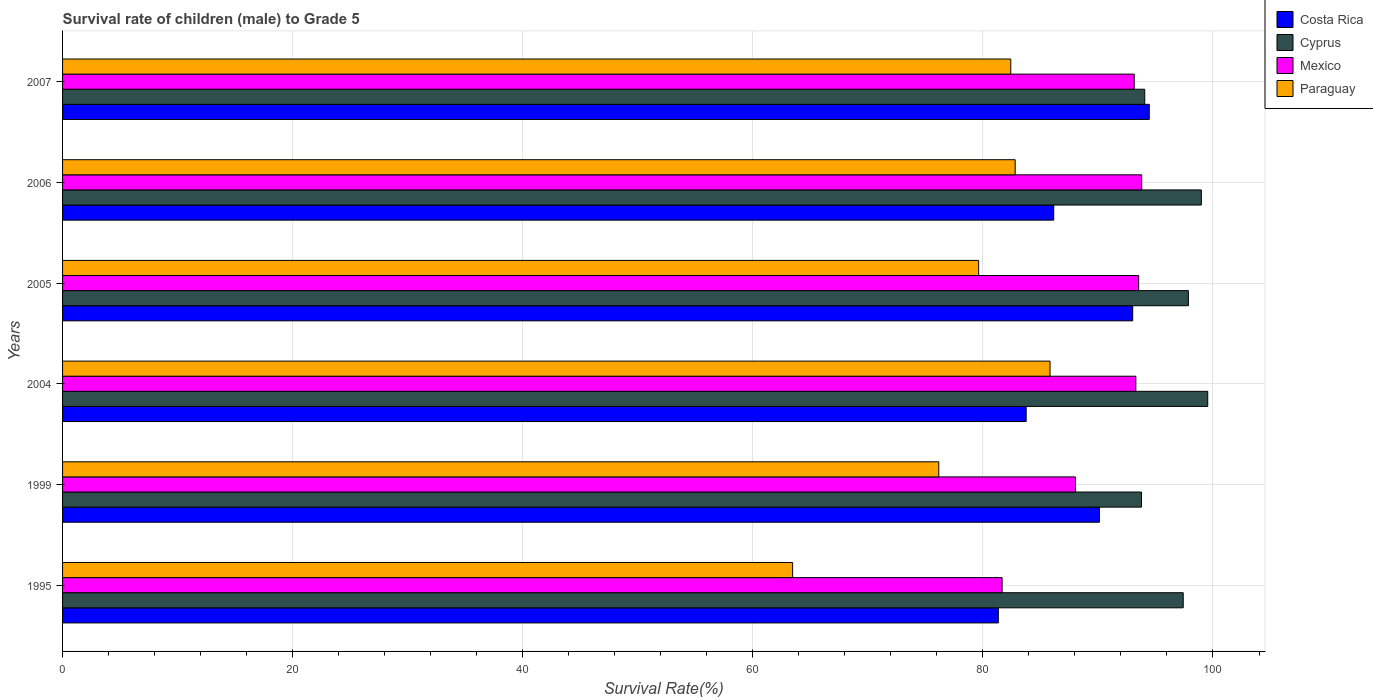How many different coloured bars are there?
Your answer should be very brief. 4. How many groups of bars are there?
Give a very brief answer. 6. Are the number of bars on each tick of the Y-axis equal?
Your answer should be very brief. Yes. How many bars are there on the 5th tick from the top?
Make the answer very short. 4. What is the label of the 2nd group of bars from the top?
Your answer should be compact. 2006. In how many cases, is the number of bars for a given year not equal to the number of legend labels?
Give a very brief answer. 0. What is the survival rate of male children to grade 5 in Paraguay in 2005?
Provide a short and direct response. 79.63. Across all years, what is the maximum survival rate of male children to grade 5 in Paraguay?
Make the answer very short. 85.84. Across all years, what is the minimum survival rate of male children to grade 5 in Cyprus?
Your response must be concise. 93.79. In which year was the survival rate of male children to grade 5 in Cyprus maximum?
Offer a very short reply. 2004. What is the total survival rate of male children to grade 5 in Paraguay in the graph?
Offer a very short reply. 470.32. What is the difference between the survival rate of male children to grade 5 in Mexico in 2005 and that in 2006?
Ensure brevity in your answer.  -0.26. What is the difference between the survival rate of male children to grade 5 in Mexico in 1995 and the survival rate of male children to grade 5 in Paraguay in 1999?
Offer a terse response. 5.5. What is the average survival rate of male children to grade 5 in Mexico per year?
Give a very brief answer. 90.58. In the year 2007, what is the difference between the survival rate of male children to grade 5 in Cyprus and survival rate of male children to grade 5 in Paraguay?
Your answer should be compact. 11.65. What is the ratio of the survival rate of male children to grade 5 in Costa Rica in 1999 to that in 2007?
Offer a very short reply. 0.95. Is the difference between the survival rate of male children to grade 5 in Cyprus in 2005 and 2007 greater than the difference between the survival rate of male children to grade 5 in Paraguay in 2005 and 2007?
Give a very brief answer. Yes. What is the difference between the highest and the second highest survival rate of male children to grade 5 in Costa Rica?
Offer a very short reply. 1.44. What is the difference between the highest and the lowest survival rate of male children to grade 5 in Mexico?
Offer a very short reply. 12.13. In how many years, is the survival rate of male children to grade 5 in Mexico greater than the average survival rate of male children to grade 5 in Mexico taken over all years?
Ensure brevity in your answer.  4. What does the 1st bar from the top in 2005 represents?
Ensure brevity in your answer.  Paraguay. What does the 2nd bar from the bottom in 2005 represents?
Give a very brief answer. Cyprus. Is it the case that in every year, the sum of the survival rate of male children to grade 5 in Mexico and survival rate of male children to grade 5 in Paraguay is greater than the survival rate of male children to grade 5 in Cyprus?
Your answer should be compact. Yes. How many bars are there?
Provide a succinct answer. 24. Does the graph contain any zero values?
Provide a short and direct response. No. How are the legend labels stacked?
Offer a very short reply. Vertical. What is the title of the graph?
Make the answer very short. Survival rate of children (male) to Grade 5. What is the label or title of the X-axis?
Provide a succinct answer. Survival Rate(%). What is the Survival Rate(%) of Costa Rica in 1995?
Offer a very short reply. 81.34. What is the Survival Rate(%) of Cyprus in 1995?
Offer a terse response. 97.41. What is the Survival Rate(%) of Mexico in 1995?
Provide a succinct answer. 81.67. What is the Survival Rate(%) in Paraguay in 1995?
Provide a succinct answer. 63.46. What is the Survival Rate(%) in Costa Rica in 1999?
Offer a very short reply. 90.13. What is the Survival Rate(%) in Cyprus in 1999?
Your answer should be very brief. 93.79. What is the Survival Rate(%) of Mexico in 1999?
Your answer should be very brief. 88.05. What is the Survival Rate(%) in Paraguay in 1999?
Make the answer very short. 76.17. What is the Survival Rate(%) in Costa Rica in 2004?
Offer a terse response. 83.76. What is the Survival Rate(%) of Cyprus in 2004?
Provide a succinct answer. 99.54. What is the Survival Rate(%) of Mexico in 2004?
Provide a short and direct response. 93.29. What is the Survival Rate(%) of Paraguay in 2004?
Offer a very short reply. 85.84. What is the Survival Rate(%) in Costa Rica in 2005?
Give a very brief answer. 93.02. What is the Survival Rate(%) of Cyprus in 2005?
Your response must be concise. 97.86. What is the Survival Rate(%) of Mexico in 2005?
Provide a short and direct response. 93.54. What is the Survival Rate(%) of Paraguay in 2005?
Give a very brief answer. 79.63. What is the Survival Rate(%) in Costa Rica in 2006?
Provide a short and direct response. 86.16. What is the Survival Rate(%) in Cyprus in 2006?
Offer a terse response. 98.99. What is the Survival Rate(%) in Mexico in 2006?
Offer a very short reply. 93.8. What is the Survival Rate(%) in Paraguay in 2006?
Make the answer very short. 82.8. What is the Survival Rate(%) in Costa Rica in 2007?
Provide a succinct answer. 94.46. What is the Survival Rate(%) of Cyprus in 2007?
Ensure brevity in your answer.  94.07. What is the Survival Rate(%) in Mexico in 2007?
Your answer should be very brief. 93.15. What is the Survival Rate(%) in Paraguay in 2007?
Provide a short and direct response. 82.42. Across all years, what is the maximum Survival Rate(%) of Costa Rica?
Give a very brief answer. 94.46. Across all years, what is the maximum Survival Rate(%) of Cyprus?
Provide a succinct answer. 99.54. Across all years, what is the maximum Survival Rate(%) in Mexico?
Make the answer very short. 93.8. Across all years, what is the maximum Survival Rate(%) of Paraguay?
Ensure brevity in your answer.  85.84. Across all years, what is the minimum Survival Rate(%) of Costa Rica?
Ensure brevity in your answer.  81.34. Across all years, what is the minimum Survival Rate(%) of Cyprus?
Provide a succinct answer. 93.79. Across all years, what is the minimum Survival Rate(%) of Mexico?
Your answer should be compact. 81.67. Across all years, what is the minimum Survival Rate(%) in Paraguay?
Keep it short and to the point. 63.46. What is the total Survival Rate(%) in Costa Rica in the graph?
Ensure brevity in your answer.  528.87. What is the total Survival Rate(%) in Cyprus in the graph?
Keep it short and to the point. 581.65. What is the total Survival Rate(%) of Mexico in the graph?
Your answer should be compact. 543.51. What is the total Survival Rate(%) in Paraguay in the graph?
Offer a very short reply. 470.32. What is the difference between the Survival Rate(%) in Costa Rica in 1995 and that in 1999?
Offer a very short reply. -8.79. What is the difference between the Survival Rate(%) of Cyprus in 1995 and that in 1999?
Provide a succinct answer. 3.63. What is the difference between the Survival Rate(%) of Mexico in 1995 and that in 1999?
Offer a terse response. -6.38. What is the difference between the Survival Rate(%) of Paraguay in 1995 and that in 1999?
Give a very brief answer. -12.71. What is the difference between the Survival Rate(%) in Costa Rica in 1995 and that in 2004?
Your answer should be compact. -2.42. What is the difference between the Survival Rate(%) of Cyprus in 1995 and that in 2004?
Provide a succinct answer. -2.13. What is the difference between the Survival Rate(%) in Mexico in 1995 and that in 2004?
Give a very brief answer. -11.63. What is the difference between the Survival Rate(%) in Paraguay in 1995 and that in 2004?
Ensure brevity in your answer.  -22.38. What is the difference between the Survival Rate(%) in Costa Rica in 1995 and that in 2005?
Offer a very short reply. -11.68. What is the difference between the Survival Rate(%) in Cyprus in 1995 and that in 2005?
Provide a succinct answer. -0.45. What is the difference between the Survival Rate(%) in Mexico in 1995 and that in 2005?
Ensure brevity in your answer.  -11.87. What is the difference between the Survival Rate(%) in Paraguay in 1995 and that in 2005?
Give a very brief answer. -16.17. What is the difference between the Survival Rate(%) of Costa Rica in 1995 and that in 2006?
Give a very brief answer. -4.82. What is the difference between the Survival Rate(%) in Cyprus in 1995 and that in 2006?
Offer a very short reply. -1.58. What is the difference between the Survival Rate(%) of Mexico in 1995 and that in 2006?
Your answer should be compact. -12.13. What is the difference between the Survival Rate(%) in Paraguay in 1995 and that in 2006?
Provide a succinct answer. -19.34. What is the difference between the Survival Rate(%) in Costa Rica in 1995 and that in 2007?
Your answer should be compact. -13.12. What is the difference between the Survival Rate(%) of Cyprus in 1995 and that in 2007?
Your answer should be very brief. 3.34. What is the difference between the Survival Rate(%) in Mexico in 1995 and that in 2007?
Provide a succinct answer. -11.48. What is the difference between the Survival Rate(%) in Paraguay in 1995 and that in 2007?
Keep it short and to the point. -18.96. What is the difference between the Survival Rate(%) in Costa Rica in 1999 and that in 2004?
Offer a terse response. 6.37. What is the difference between the Survival Rate(%) of Cyprus in 1999 and that in 2004?
Offer a terse response. -5.76. What is the difference between the Survival Rate(%) of Mexico in 1999 and that in 2004?
Ensure brevity in your answer.  -5.24. What is the difference between the Survival Rate(%) of Paraguay in 1999 and that in 2004?
Provide a succinct answer. -9.67. What is the difference between the Survival Rate(%) in Costa Rica in 1999 and that in 2005?
Offer a terse response. -2.89. What is the difference between the Survival Rate(%) in Cyprus in 1999 and that in 2005?
Offer a very short reply. -4.08. What is the difference between the Survival Rate(%) in Mexico in 1999 and that in 2005?
Your answer should be very brief. -5.49. What is the difference between the Survival Rate(%) in Paraguay in 1999 and that in 2005?
Keep it short and to the point. -3.46. What is the difference between the Survival Rate(%) of Costa Rica in 1999 and that in 2006?
Keep it short and to the point. 3.97. What is the difference between the Survival Rate(%) of Cyprus in 1999 and that in 2006?
Offer a very short reply. -5.2. What is the difference between the Survival Rate(%) in Mexico in 1999 and that in 2006?
Keep it short and to the point. -5.75. What is the difference between the Survival Rate(%) in Paraguay in 1999 and that in 2006?
Your response must be concise. -6.64. What is the difference between the Survival Rate(%) in Costa Rica in 1999 and that in 2007?
Ensure brevity in your answer.  -4.33. What is the difference between the Survival Rate(%) in Cyprus in 1999 and that in 2007?
Provide a short and direct response. -0.28. What is the difference between the Survival Rate(%) in Mexico in 1999 and that in 2007?
Your answer should be very brief. -5.1. What is the difference between the Survival Rate(%) in Paraguay in 1999 and that in 2007?
Keep it short and to the point. -6.26. What is the difference between the Survival Rate(%) of Costa Rica in 2004 and that in 2005?
Provide a succinct answer. -9.26. What is the difference between the Survival Rate(%) in Cyprus in 2004 and that in 2005?
Your answer should be compact. 1.68. What is the difference between the Survival Rate(%) in Mexico in 2004 and that in 2005?
Your response must be concise. -0.24. What is the difference between the Survival Rate(%) of Paraguay in 2004 and that in 2005?
Your answer should be very brief. 6.21. What is the difference between the Survival Rate(%) in Costa Rica in 2004 and that in 2006?
Ensure brevity in your answer.  -2.39. What is the difference between the Survival Rate(%) of Cyprus in 2004 and that in 2006?
Offer a very short reply. 0.56. What is the difference between the Survival Rate(%) in Mexico in 2004 and that in 2006?
Ensure brevity in your answer.  -0.51. What is the difference between the Survival Rate(%) in Paraguay in 2004 and that in 2006?
Your response must be concise. 3.03. What is the difference between the Survival Rate(%) of Costa Rica in 2004 and that in 2007?
Offer a terse response. -10.7. What is the difference between the Survival Rate(%) in Cyprus in 2004 and that in 2007?
Ensure brevity in your answer.  5.48. What is the difference between the Survival Rate(%) in Mexico in 2004 and that in 2007?
Make the answer very short. 0.14. What is the difference between the Survival Rate(%) of Paraguay in 2004 and that in 2007?
Your answer should be very brief. 3.42. What is the difference between the Survival Rate(%) of Costa Rica in 2005 and that in 2006?
Offer a very short reply. 6.87. What is the difference between the Survival Rate(%) in Cyprus in 2005 and that in 2006?
Keep it short and to the point. -1.13. What is the difference between the Survival Rate(%) of Mexico in 2005 and that in 2006?
Your answer should be very brief. -0.26. What is the difference between the Survival Rate(%) in Paraguay in 2005 and that in 2006?
Provide a short and direct response. -3.17. What is the difference between the Survival Rate(%) of Costa Rica in 2005 and that in 2007?
Your answer should be very brief. -1.44. What is the difference between the Survival Rate(%) in Cyprus in 2005 and that in 2007?
Your answer should be compact. 3.79. What is the difference between the Survival Rate(%) of Mexico in 2005 and that in 2007?
Ensure brevity in your answer.  0.39. What is the difference between the Survival Rate(%) in Paraguay in 2005 and that in 2007?
Your answer should be very brief. -2.79. What is the difference between the Survival Rate(%) of Costa Rica in 2006 and that in 2007?
Ensure brevity in your answer.  -8.31. What is the difference between the Survival Rate(%) in Cyprus in 2006 and that in 2007?
Your response must be concise. 4.92. What is the difference between the Survival Rate(%) of Mexico in 2006 and that in 2007?
Make the answer very short. 0.65. What is the difference between the Survival Rate(%) of Paraguay in 2006 and that in 2007?
Make the answer very short. 0.38. What is the difference between the Survival Rate(%) of Costa Rica in 1995 and the Survival Rate(%) of Cyprus in 1999?
Ensure brevity in your answer.  -12.45. What is the difference between the Survival Rate(%) of Costa Rica in 1995 and the Survival Rate(%) of Mexico in 1999?
Your answer should be compact. -6.71. What is the difference between the Survival Rate(%) in Costa Rica in 1995 and the Survival Rate(%) in Paraguay in 1999?
Your response must be concise. 5.17. What is the difference between the Survival Rate(%) in Cyprus in 1995 and the Survival Rate(%) in Mexico in 1999?
Provide a succinct answer. 9.36. What is the difference between the Survival Rate(%) in Cyprus in 1995 and the Survival Rate(%) in Paraguay in 1999?
Offer a terse response. 21.25. What is the difference between the Survival Rate(%) in Mexico in 1995 and the Survival Rate(%) in Paraguay in 1999?
Keep it short and to the point. 5.5. What is the difference between the Survival Rate(%) of Costa Rica in 1995 and the Survival Rate(%) of Cyprus in 2004?
Offer a very short reply. -18.2. What is the difference between the Survival Rate(%) of Costa Rica in 1995 and the Survival Rate(%) of Mexico in 2004?
Make the answer very short. -11.95. What is the difference between the Survival Rate(%) of Costa Rica in 1995 and the Survival Rate(%) of Paraguay in 2004?
Make the answer very short. -4.5. What is the difference between the Survival Rate(%) in Cyprus in 1995 and the Survival Rate(%) in Mexico in 2004?
Keep it short and to the point. 4.12. What is the difference between the Survival Rate(%) in Cyprus in 1995 and the Survival Rate(%) in Paraguay in 2004?
Give a very brief answer. 11.57. What is the difference between the Survival Rate(%) of Mexico in 1995 and the Survival Rate(%) of Paraguay in 2004?
Make the answer very short. -4.17. What is the difference between the Survival Rate(%) in Costa Rica in 1995 and the Survival Rate(%) in Cyprus in 2005?
Make the answer very short. -16.52. What is the difference between the Survival Rate(%) in Costa Rica in 1995 and the Survival Rate(%) in Mexico in 2005?
Provide a short and direct response. -12.2. What is the difference between the Survival Rate(%) in Costa Rica in 1995 and the Survival Rate(%) in Paraguay in 2005?
Provide a short and direct response. 1.71. What is the difference between the Survival Rate(%) in Cyprus in 1995 and the Survival Rate(%) in Mexico in 2005?
Offer a very short reply. 3.87. What is the difference between the Survival Rate(%) in Cyprus in 1995 and the Survival Rate(%) in Paraguay in 2005?
Your answer should be compact. 17.78. What is the difference between the Survival Rate(%) in Mexico in 1995 and the Survival Rate(%) in Paraguay in 2005?
Give a very brief answer. 2.04. What is the difference between the Survival Rate(%) in Costa Rica in 1995 and the Survival Rate(%) in Cyprus in 2006?
Give a very brief answer. -17.65. What is the difference between the Survival Rate(%) in Costa Rica in 1995 and the Survival Rate(%) in Mexico in 2006?
Offer a very short reply. -12.46. What is the difference between the Survival Rate(%) of Costa Rica in 1995 and the Survival Rate(%) of Paraguay in 2006?
Ensure brevity in your answer.  -1.46. What is the difference between the Survival Rate(%) of Cyprus in 1995 and the Survival Rate(%) of Mexico in 2006?
Your response must be concise. 3.61. What is the difference between the Survival Rate(%) in Cyprus in 1995 and the Survival Rate(%) in Paraguay in 2006?
Offer a terse response. 14.61. What is the difference between the Survival Rate(%) of Mexico in 1995 and the Survival Rate(%) of Paraguay in 2006?
Provide a succinct answer. -1.14. What is the difference between the Survival Rate(%) in Costa Rica in 1995 and the Survival Rate(%) in Cyprus in 2007?
Offer a terse response. -12.73. What is the difference between the Survival Rate(%) of Costa Rica in 1995 and the Survival Rate(%) of Mexico in 2007?
Provide a succinct answer. -11.81. What is the difference between the Survival Rate(%) in Costa Rica in 1995 and the Survival Rate(%) in Paraguay in 2007?
Offer a terse response. -1.08. What is the difference between the Survival Rate(%) in Cyprus in 1995 and the Survival Rate(%) in Mexico in 2007?
Offer a terse response. 4.26. What is the difference between the Survival Rate(%) in Cyprus in 1995 and the Survival Rate(%) in Paraguay in 2007?
Your answer should be compact. 14.99. What is the difference between the Survival Rate(%) in Mexico in 1995 and the Survival Rate(%) in Paraguay in 2007?
Provide a succinct answer. -0.75. What is the difference between the Survival Rate(%) in Costa Rica in 1999 and the Survival Rate(%) in Cyprus in 2004?
Your answer should be very brief. -9.42. What is the difference between the Survival Rate(%) in Costa Rica in 1999 and the Survival Rate(%) in Mexico in 2004?
Provide a succinct answer. -3.17. What is the difference between the Survival Rate(%) of Costa Rica in 1999 and the Survival Rate(%) of Paraguay in 2004?
Provide a short and direct response. 4.29. What is the difference between the Survival Rate(%) of Cyprus in 1999 and the Survival Rate(%) of Mexico in 2004?
Offer a terse response. 0.49. What is the difference between the Survival Rate(%) in Cyprus in 1999 and the Survival Rate(%) in Paraguay in 2004?
Offer a terse response. 7.95. What is the difference between the Survival Rate(%) in Mexico in 1999 and the Survival Rate(%) in Paraguay in 2004?
Your response must be concise. 2.21. What is the difference between the Survival Rate(%) of Costa Rica in 1999 and the Survival Rate(%) of Cyprus in 2005?
Keep it short and to the point. -7.73. What is the difference between the Survival Rate(%) in Costa Rica in 1999 and the Survival Rate(%) in Mexico in 2005?
Give a very brief answer. -3.41. What is the difference between the Survival Rate(%) in Costa Rica in 1999 and the Survival Rate(%) in Paraguay in 2005?
Make the answer very short. 10.5. What is the difference between the Survival Rate(%) of Cyprus in 1999 and the Survival Rate(%) of Mexico in 2005?
Make the answer very short. 0.25. What is the difference between the Survival Rate(%) in Cyprus in 1999 and the Survival Rate(%) in Paraguay in 2005?
Give a very brief answer. 14.16. What is the difference between the Survival Rate(%) in Mexico in 1999 and the Survival Rate(%) in Paraguay in 2005?
Ensure brevity in your answer.  8.42. What is the difference between the Survival Rate(%) of Costa Rica in 1999 and the Survival Rate(%) of Cyprus in 2006?
Your answer should be very brief. -8.86. What is the difference between the Survival Rate(%) in Costa Rica in 1999 and the Survival Rate(%) in Mexico in 2006?
Provide a short and direct response. -3.68. What is the difference between the Survival Rate(%) in Costa Rica in 1999 and the Survival Rate(%) in Paraguay in 2006?
Make the answer very short. 7.32. What is the difference between the Survival Rate(%) in Cyprus in 1999 and the Survival Rate(%) in Mexico in 2006?
Make the answer very short. -0.02. What is the difference between the Survival Rate(%) of Cyprus in 1999 and the Survival Rate(%) of Paraguay in 2006?
Give a very brief answer. 10.98. What is the difference between the Survival Rate(%) in Mexico in 1999 and the Survival Rate(%) in Paraguay in 2006?
Your answer should be compact. 5.25. What is the difference between the Survival Rate(%) of Costa Rica in 1999 and the Survival Rate(%) of Cyprus in 2007?
Ensure brevity in your answer.  -3.94. What is the difference between the Survival Rate(%) of Costa Rica in 1999 and the Survival Rate(%) of Mexico in 2007?
Keep it short and to the point. -3.02. What is the difference between the Survival Rate(%) of Costa Rica in 1999 and the Survival Rate(%) of Paraguay in 2007?
Offer a terse response. 7.71. What is the difference between the Survival Rate(%) of Cyprus in 1999 and the Survival Rate(%) of Mexico in 2007?
Your answer should be very brief. 0.63. What is the difference between the Survival Rate(%) of Cyprus in 1999 and the Survival Rate(%) of Paraguay in 2007?
Offer a very short reply. 11.36. What is the difference between the Survival Rate(%) in Mexico in 1999 and the Survival Rate(%) in Paraguay in 2007?
Provide a succinct answer. 5.63. What is the difference between the Survival Rate(%) in Costa Rica in 2004 and the Survival Rate(%) in Cyprus in 2005?
Your answer should be very brief. -14.1. What is the difference between the Survival Rate(%) of Costa Rica in 2004 and the Survival Rate(%) of Mexico in 2005?
Make the answer very short. -9.78. What is the difference between the Survival Rate(%) of Costa Rica in 2004 and the Survival Rate(%) of Paraguay in 2005?
Offer a very short reply. 4.13. What is the difference between the Survival Rate(%) in Cyprus in 2004 and the Survival Rate(%) in Mexico in 2005?
Provide a short and direct response. 6. What is the difference between the Survival Rate(%) of Cyprus in 2004 and the Survival Rate(%) of Paraguay in 2005?
Ensure brevity in your answer.  19.91. What is the difference between the Survival Rate(%) of Mexico in 2004 and the Survival Rate(%) of Paraguay in 2005?
Your response must be concise. 13.66. What is the difference between the Survival Rate(%) in Costa Rica in 2004 and the Survival Rate(%) in Cyprus in 2006?
Your answer should be compact. -15.23. What is the difference between the Survival Rate(%) of Costa Rica in 2004 and the Survival Rate(%) of Mexico in 2006?
Give a very brief answer. -10.04. What is the difference between the Survival Rate(%) in Costa Rica in 2004 and the Survival Rate(%) in Paraguay in 2006?
Keep it short and to the point. 0.96. What is the difference between the Survival Rate(%) of Cyprus in 2004 and the Survival Rate(%) of Mexico in 2006?
Keep it short and to the point. 5.74. What is the difference between the Survival Rate(%) in Cyprus in 2004 and the Survival Rate(%) in Paraguay in 2006?
Your response must be concise. 16.74. What is the difference between the Survival Rate(%) in Mexico in 2004 and the Survival Rate(%) in Paraguay in 2006?
Your response must be concise. 10.49. What is the difference between the Survival Rate(%) of Costa Rica in 2004 and the Survival Rate(%) of Cyprus in 2007?
Keep it short and to the point. -10.31. What is the difference between the Survival Rate(%) in Costa Rica in 2004 and the Survival Rate(%) in Mexico in 2007?
Give a very brief answer. -9.39. What is the difference between the Survival Rate(%) in Costa Rica in 2004 and the Survival Rate(%) in Paraguay in 2007?
Keep it short and to the point. 1.34. What is the difference between the Survival Rate(%) of Cyprus in 2004 and the Survival Rate(%) of Mexico in 2007?
Your answer should be compact. 6.39. What is the difference between the Survival Rate(%) in Cyprus in 2004 and the Survival Rate(%) in Paraguay in 2007?
Provide a short and direct response. 17.12. What is the difference between the Survival Rate(%) in Mexico in 2004 and the Survival Rate(%) in Paraguay in 2007?
Make the answer very short. 10.87. What is the difference between the Survival Rate(%) of Costa Rica in 2005 and the Survival Rate(%) of Cyprus in 2006?
Make the answer very short. -5.97. What is the difference between the Survival Rate(%) in Costa Rica in 2005 and the Survival Rate(%) in Mexico in 2006?
Make the answer very short. -0.78. What is the difference between the Survival Rate(%) of Costa Rica in 2005 and the Survival Rate(%) of Paraguay in 2006?
Make the answer very short. 10.22. What is the difference between the Survival Rate(%) in Cyprus in 2005 and the Survival Rate(%) in Mexico in 2006?
Your answer should be very brief. 4.06. What is the difference between the Survival Rate(%) of Cyprus in 2005 and the Survival Rate(%) of Paraguay in 2006?
Provide a succinct answer. 15.06. What is the difference between the Survival Rate(%) of Mexico in 2005 and the Survival Rate(%) of Paraguay in 2006?
Ensure brevity in your answer.  10.73. What is the difference between the Survival Rate(%) in Costa Rica in 2005 and the Survival Rate(%) in Cyprus in 2007?
Give a very brief answer. -1.05. What is the difference between the Survival Rate(%) in Costa Rica in 2005 and the Survival Rate(%) in Mexico in 2007?
Provide a short and direct response. -0.13. What is the difference between the Survival Rate(%) in Costa Rica in 2005 and the Survival Rate(%) in Paraguay in 2007?
Offer a terse response. 10.6. What is the difference between the Survival Rate(%) in Cyprus in 2005 and the Survival Rate(%) in Mexico in 2007?
Offer a terse response. 4.71. What is the difference between the Survival Rate(%) in Cyprus in 2005 and the Survival Rate(%) in Paraguay in 2007?
Provide a succinct answer. 15.44. What is the difference between the Survival Rate(%) of Mexico in 2005 and the Survival Rate(%) of Paraguay in 2007?
Offer a very short reply. 11.12. What is the difference between the Survival Rate(%) of Costa Rica in 2006 and the Survival Rate(%) of Cyprus in 2007?
Give a very brief answer. -7.91. What is the difference between the Survival Rate(%) of Costa Rica in 2006 and the Survival Rate(%) of Mexico in 2007?
Your response must be concise. -7. What is the difference between the Survival Rate(%) in Costa Rica in 2006 and the Survival Rate(%) in Paraguay in 2007?
Your answer should be compact. 3.73. What is the difference between the Survival Rate(%) in Cyprus in 2006 and the Survival Rate(%) in Mexico in 2007?
Provide a short and direct response. 5.84. What is the difference between the Survival Rate(%) of Cyprus in 2006 and the Survival Rate(%) of Paraguay in 2007?
Provide a short and direct response. 16.57. What is the difference between the Survival Rate(%) of Mexico in 2006 and the Survival Rate(%) of Paraguay in 2007?
Your answer should be very brief. 11.38. What is the average Survival Rate(%) of Costa Rica per year?
Make the answer very short. 88.14. What is the average Survival Rate(%) in Cyprus per year?
Your answer should be compact. 96.94. What is the average Survival Rate(%) in Mexico per year?
Ensure brevity in your answer.  90.58. What is the average Survival Rate(%) in Paraguay per year?
Keep it short and to the point. 78.39. In the year 1995, what is the difference between the Survival Rate(%) in Costa Rica and Survival Rate(%) in Cyprus?
Offer a terse response. -16.07. In the year 1995, what is the difference between the Survival Rate(%) in Costa Rica and Survival Rate(%) in Mexico?
Give a very brief answer. -0.33. In the year 1995, what is the difference between the Survival Rate(%) in Costa Rica and Survival Rate(%) in Paraguay?
Make the answer very short. 17.88. In the year 1995, what is the difference between the Survival Rate(%) in Cyprus and Survival Rate(%) in Mexico?
Ensure brevity in your answer.  15.74. In the year 1995, what is the difference between the Survival Rate(%) of Cyprus and Survival Rate(%) of Paraguay?
Give a very brief answer. 33.95. In the year 1995, what is the difference between the Survival Rate(%) of Mexico and Survival Rate(%) of Paraguay?
Offer a very short reply. 18.21. In the year 1999, what is the difference between the Survival Rate(%) of Costa Rica and Survival Rate(%) of Cyprus?
Your answer should be compact. -3.66. In the year 1999, what is the difference between the Survival Rate(%) in Costa Rica and Survival Rate(%) in Mexico?
Offer a very short reply. 2.08. In the year 1999, what is the difference between the Survival Rate(%) in Costa Rica and Survival Rate(%) in Paraguay?
Provide a succinct answer. 13.96. In the year 1999, what is the difference between the Survival Rate(%) in Cyprus and Survival Rate(%) in Mexico?
Your answer should be very brief. 5.74. In the year 1999, what is the difference between the Survival Rate(%) of Cyprus and Survival Rate(%) of Paraguay?
Ensure brevity in your answer.  17.62. In the year 1999, what is the difference between the Survival Rate(%) of Mexico and Survival Rate(%) of Paraguay?
Provide a short and direct response. 11.88. In the year 2004, what is the difference between the Survival Rate(%) of Costa Rica and Survival Rate(%) of Cyprus?
Ensure brevity in your answer.  -15.78. In the year 2004, what is the difference between the Survival Rate(%) of Costa Rica and Survival Rate(%) of Mexico?
Keep it short and to the point. -9.53. In the year 2004, what is the difference between the Survival Rate(%) in Costa Rica and Survival Rate(%) in Paraguay?
Your answer should be very brief. -2.08. In the year 2004, what is the difference between the Survival Rate(%) of Cyprus and Survival Rate(%) of Mexico?
Your response must be concise. 6.25. In the year 2004, what is the difference between the Survival Rate(%) in Cyprus and Survival Rate(%) in Paraguay?
Provide a short and direct response. 13.71. In the year 2004, what is the difference between the Survival Rate(%) in Mexico and Survival Rate(%) in Paraguay?
Offer a very short reply. 7.46. In the year 2005, what is the difference between the Survival Rate(%) of Costa Rica and Survival Rate(%) of Cyprus?
Give a very brief answer. -4.84. In the year 2005, what is the difference between the Survival Rate(%) of Costa Rica and Survival Rate(%) of Mexico?
Provide a short and direct response. -0.52. In the year 2005, what is the difference between the Survival Rate(%) in Costa Rica and Survival Rate(%) in Paraguay?
Provide a succinct answer. 13.39. In the year 2005, what is the difference between the Survival Rate(%) in Cyprus and Survival Rate(%) in Mexico?
Your answer should be very brief. 4.32. In the year 2005, what is the difference between the Survival Rate(%) of Cyprus and Survival Rate(%) of Paraguay?
Keep it short and to the point. 18.23. In the year 2005, what is the difference between the Survival Rate(%) in Mexico and Survival Rate(%) in Paraguay?
Provide a succinct answer. 13.91. In the year 2006, what is the difference between the Survival Rate(%) in Costa Rica and Survival Rate(%) in Cyprus?
Ensure brevity in your answer.  -12.83. In the year 2006, what is the difference between the Survival Rate(%) in Costa Rica and Survival Rate(%) in Mexico?
Your answer should be very brief. -7.65. In the year 2006, what is the difference between the Survival Rate(%) in Costa Rica and Survival Rate(%) in Paraguay?
Offer a very short reply. 3.35. In the year 2006, what is the difference between the Survival Rate(%) of Cyprus and Survival Rate(%) of Mexico?
Provide a short and direct response. 5.18. In the year 2006, what is the difference between the Survival Rate(%) in Cyprus and Survival Rate(%) in Paraguay?
Your answer should be compact. 16.18. In the year 2006, what is the difference between the Survival Rate(%) of Mexico and Survival Rate(%) of Paraguay?
Ensure brevity in your answer.  11. In the year 2007, what is the difference between the Survival Rate(%) of Costa Rica and Survival Rate(%) of Cyprus?
Your response must be concise. 0.39. In the year 2007, what is the difference between the Survival Rate(%) of Costa Rica and Survival Rate(%) of Mexico?
Offer a terse response. 1.31. In the year 2007, what is the difference between the Survival Rate(%) of Costa Rica and Survival Rate(%) of Paraguay?
Your answer should be compact. 12.04. In the year 2007, what is the difference between the Survival Rate(%) of Cyprus and Survival Rate(%) of Mexico?
Offer a very short reply. 0.92. In the year 2007, what is the difference between the Survival Rate(%) in Cyprus and Survival Rate(%) in Paraguay?
Ensure brevity in your answer.  11.65. In the year 2007, what is the difference between the Survival Rate(%) of Mexico and Survival Rate(%) of Paraguay?
Ensure brevity in your answer.  10.73. What is the ratio of the Survival Rate(%) in Costa Rica in 1995 to that in 1999?
Your response must be concise. 0.9. What is the ratio of the Survival Rate(%) in Cyprus in 1995 to that in 1999?
Your answer should be compact. 1.04. What is the ratio of the Survival Rate(%) in Mexico in 1995 to that in 1999?
Your response must be concise. 0.93. What is the ratio of the Survival Rate(%) of Paraguay in 1995 to that in 1999?
Provide a succinct answer. 0.83. What is the ratio of the Survival Rate(%) of Costa Rica in 1995 to that in 2004?
Offer a very short reply. 0.97. What is the ratio of the Survival Rate(%) in Cyprus in 1995 to that in 2004?
Your answer should be compact. 0.98. What is the ratio of the Survival Rate(%) in Mexico in 1995 to that in 2004?
Ensure brevity in your answer.  0.88. What is the ratio of the Survival Rate(%) in Paraguay in 1995 to that in 2004?
Offer a very short reply. 0.74. What is the ratio of the Survival Rate(%) in Costa Rica in 1995 to that in 2005?
Make the answer very short. 0.87. What is the ratio of the Survival Rate(%) in Cyprus in 1995 to that in 2005?
Provide a succinct answer. 1. What is the ratio of the Survival Rate(%) in Mexico in 1995 to that in 2005?
Make the answer very short. 0.87. What is the ratio of the Survival Rate(%) of Paraguay in 1995 to that in 2005?
Make the answer very short. 0.8. What is the ratio of the Survival Rate(%) in Costa Rica in 1995 to that in 2006?
Provide a short and direct response. 0.94. What is the ratio of the Survival Rate(%) in Cyprus in 1995 to that in 2006?
Ensure brevity in your answer.  0.98. What is the ratio of the Survival Rate(%) in Mexico in 1995 to that in 2006?
Provide a succinct answer. 0.87. What is the ratio of the Survival Rate(%) in Paraguay in 1995 to that in 2006?
Make the answer very short. 0.77. What is the ratio of the Survival Rate(%) of Costa Rica in 1995 to that in 2007?
Give a very brief answer. 0.86. What is the ratio of the Survival Rate(%) of Cyprus in 1995 to that in 2007?
Your answer should be very brief. 1.04. What is the ratio of the Survival Rate(%) in Mexico in 1995 to that in 2007?
Provide a succinct answer. 0.88. What is the ratio of the Survival Rate(%) of Paraguay in 1995 to that in 2007?
Make the answer very short. 0.77. What is the ratio of the Survival Rate(%) in Costa Rica in 1999 to that in 2004?
Give a very brief answer. 1.08. What is the ratio of the Survival Rate(%) in Cyprus in 1999 to that in 2004?
Your answer should be very brief. 0.94. What is the ratio of the Survival Rate(%) in Mexico in 1999 to that in 2004?
Your answer should be compact. 0.94. What is the ratio of the Survival Rate(%) in Paraguay in 1999 to that in 2004?
Keep it short and to the point. 0.89. What is the ratio of the Survival Rate(%) of Costa Rica in 1999 to that in 2005?
Make the answer very short. 0.97. What is the ratio of the Survival Rate(%) in Cyprus in 1999 to that in 2005?
Ensure brevity in your answer.  0.96. What is the ratio of the Survival Rate(%) in Mexico in 1999 to that in 2005?
Offer a terse response. 0.94. What is the ratio of the Survival Rate(%) of Paraguay in 1999 to that in 2005?
Your answer should be compact. 0.96. What is the ratio of the Survival Rate(%) in Costa Rica in 1999 to that in 2006?
Make the answer very short. 1.05. What is the ratio of the Survival Rate(%) of Cyprus in 1999 to that in 2006?
Offer a very short reply. 0.95. What is the ratio of the Survival Rate(%) in Mexico in 1999 to that in 2006?
Offer a very short reply. 0.94. What is the ratio of the Survival Rate(%) in Paraguay in 1999 to that in 2006?
Provide a succinct answer. 0.92. What is the ratio of the Survival Rate(%) in Costa Rica in 1999 to that in 2007?
Offer a very short reply. 0.95. What is the ratio of the Survival Rate(%) of Mexico in 1999 to that in 2007?
Ensure brevity in your answer.  0.95. What is the ratio of the Survival Rate(%) in Paraguay in 1999 to that in 2007?
Your response must be concise. 0.92. What is the ratio of the Survival Rate(%) in Costa Rica in 2004 to that in 2005?
Your answer should be very brief. 0.9. What is the ratio of the Survival Rate(%) in Cyprus in 2004 to that in 2005?
Offer a very short reply. 1.02. What is the ratio of the Survival Rate(%) in Paraguay in 2004 to that in 2005?
Offer a very short reply. 1.08. What is the ratio of the Survival Rate(%) of Costa Rica in 2004 to that in 2006?
Your response must be concise. 0.97. What is the ratio of the Survival Rate(%) in Cyprus in 2004 to that in 2006?
Give a very brief answer. 1.01. What is the ratio of the Survival Rate(%) in Mexico in 2004 to that in 2006?
Your response must be concise. 0.99. What is the ratio of the Survival Rate(%) of Paraguay in 2004 to that in 2006?
Offer a terse response. 1.04. What is the ratio of the Survival Rate(%) of Costa Rica in 2004 to that in 2007?
Keep it short and to the point. 0.89. What is the ratio of the Survival Rate(%) of Cyprus in 2004 to that in 2007?
Make the answer very short. 1.06. What is the ratio of the Survival Rate(%) in Paraguay in 2004 to that in 2007?
Make the answer very short. 1.04. What is the ratio of the Survival Rate(%) of Costa Rica in 2005 to that in 2006?
Make the answer very short. 1.08. What is the ratio of the Survival Rate(%) in Mexico in 2005 to that in 2006?
Offer a terse response. 1. What is the ratio of the Survival Rate(%) of Paraguay in 2005 to that in 2006?
Provide a short and direct response. 0.96. What is the ratio of the Survival Rate(%) in Cyprus in 2005 to that in 2007?
Ensure brevity in your answer.  1.04. What is the ratio of the Survival Rate(%) of Paraguay in 2005 to that in 2007?
Your answer should be very brief. 0.97. What is the ratio of the Survival Rate(%) of Costa Rica in 2006 to that in 2007?
Keep it short and to the point. 0.91. What is the ratio of the Survival Rate(%) in Cyprus in 2006 to that in 2007?
Your answer should be compact. 1.05. What is the difference between the highest and the second highest Survival Rate(%) in Costa Rica?
Offer a very short reply. 1.44. What is the difference between the highest and the second highest Survival Rate(%) of Cyprus?
Keep it short and to the point. 0.56. What is the difference between the highest and the second highest Survival Rate(%) in Mexico?
Your response must be concise. 0.26. What is the difference between the highest and the second highest Survival Rate(%) of Paraguay?
Your response must be concise. 3.03. What is the difference between the highest and the lowest Survival Rate(%) of Costa Rica?
Your answer should be very brief. 13.12. What is the difference between the highest and the lowest Survival Rate(%) in Cyprus?
Provide a succinct answer. 5.76. What is the difference between the highest and the lowest Survival Rate(%) of Mexico?
Your response must be concise. 12.13. What is the difference between the highest and the lowest Survival Rate(%) in Paraguay?
Give a very brief answer. 22.38. 